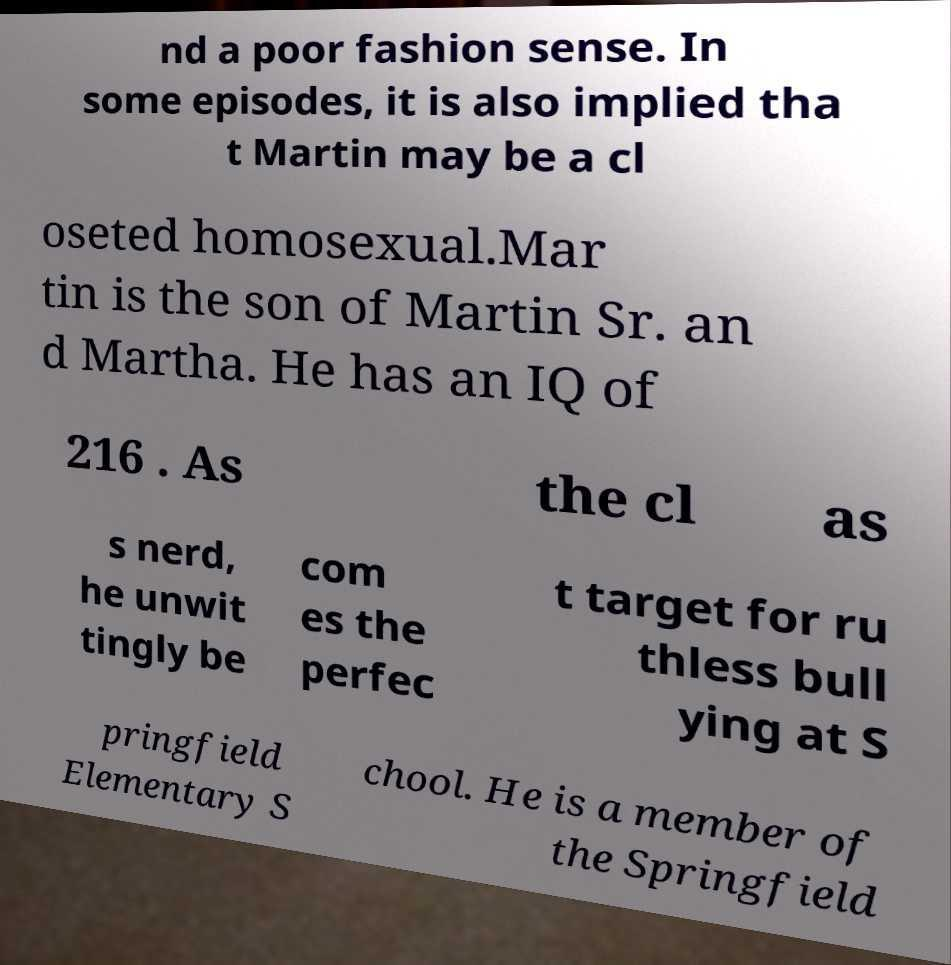What messages or text are displayed in this image? I need them in a readable, typed format. nd a poor fashion sense. In some episodes, it is also implied tha t Martin may be a cl oseted homosexual.Mar tin is the son of Martin Sr. an d Martha. He has an IQ of 216 . As the cl as s nerd, he unwit tingly be com es the perfec t target for ru thless bull ying at S pringfield Elementary S chool. He is a member of the Springfield 